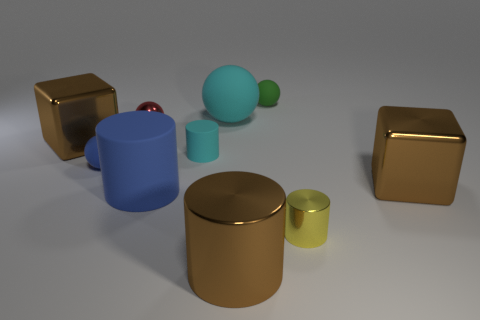What number of big brown metal cylinders are there?
Make the answer very short. 1. Are there any green balls that have the same material as the tiny cyan object?
Offer a very short reply. Yes. What size is the matte sphere that is the same color as the tiny matte cylinder?
Your response must be concise. Large. Do the brown cylinder that is in front of the red object and the red metallic thing that is left of the small yellow metallic thing have the same size?
Offer a very short reply. No. There is a brown metallic block that is on the right side of the cyan matte ball; what size is it?
Your response must be concise. Large. Is there a matte ball of the same color as the large matte cylinder?
Give a very brief answer. Yes. There is a brown shiny cube to the left of the small yellow shiny object; is there a brown object that is right of it?
Your answer should be compact. Yes. Is the size of the shiny ball the same as the cube on the left side of the small green matte thing?
Your response must be concise. No. There is a ball in front of the brown block that is left of the large blue object; is there a tiny yellow metallic cylinder that is behind it?
Provide a short and direct response. No. There is a tiny blue sphere to the left of the green object; what is its material?
Offer a very short reply. Rubber. 